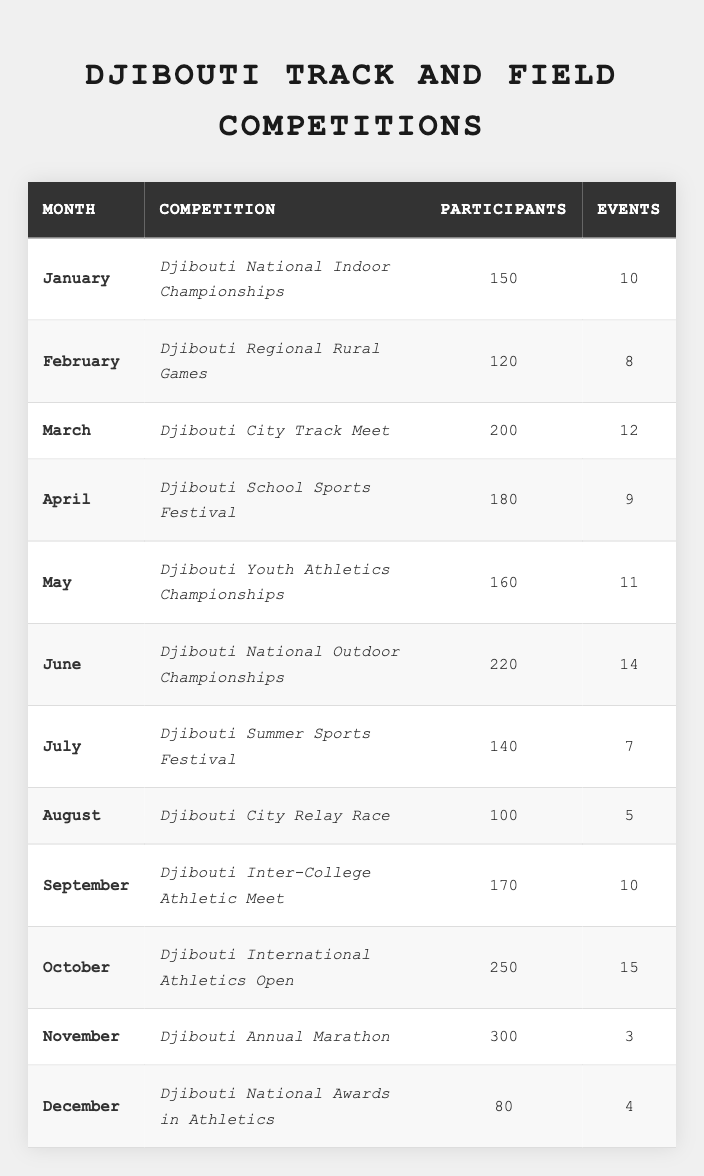What is the highest number of participants in a single competition? The highest number of participants in the table is found by comparing the participants column. The Djibouti Annual Marathon has 300 participants, which is the highest among all competitions listed.
Answer: 300 Which competition had the least number of events? By reviewing the events column, we see that the Djibouti Annual Marathon had only 3 events, which is the least compared to other competitions listed.
Answer: Djibouti Annual Marathon What was the total number of participants across all competitions in January, February, and March? Adding the participants for January (150), February (120), and March (200): 150 + 120 + 200 = 470.
Answer: 470 Which month had the most competitions with more than 200 participants? Looking at the table, we only see one month, October, which had 250 participants and is the only instance of a competition with more than 200 participants. Thus, the answer is October.
Answer: October What is the average number of participants per event for the Djibouti National Outdoor Championships? The number of participants for the Djibouti National Outdoor Championships is 220 and there are 14 events. Therefore, the average is calculated as 220 / 14 = 15.71 (approximately).
Answer: 15.71 Which month had the lowest competition in terms of both participants and events? The month of December has both the lowest number of participants (80) and the lowest number of events (4). Comparing December to other months, it is defined as the month with the lowest metrics.
Answer: December How many competitions had more than 10 events? By reviewing the events column, we find that there are three competitions with more than 10 events: Djibouti City Track Meet (12), Djibouti National Outdoor Championships (14), and Djibouti International Athletics Open (15). Therefore, there are three competitions with more than 10 events.
Answer: 3 Did any month have 100 participants or less? Checking the participants column, we see that the only month with 100 participants or less is August, which had exactly 100 participants. Therefore, the answer is yes.
Answer: Yes Which competition took place in April and how many participants did it have? In the month of April, the competition listed is the Djibouti School Sports Festival, which had 180 participants.
Answer: Djibouti School Sports Festival, 180 What is the median number of participants for all competitions listed? First, we list the participants from all competitions in ascending order: 80, 100, 120, 140, 150, 160, 170, 180, 200, 220, 250, 300. With 12 values, the median is the average of the 6th and 7th values: (160 + 170) / 2 = 165.
Answer: 165 